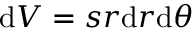Convert formula to latex. <formula><loc_0><loc_0><loc_500><loc_500>d V = s r d r d \theta</formula> 